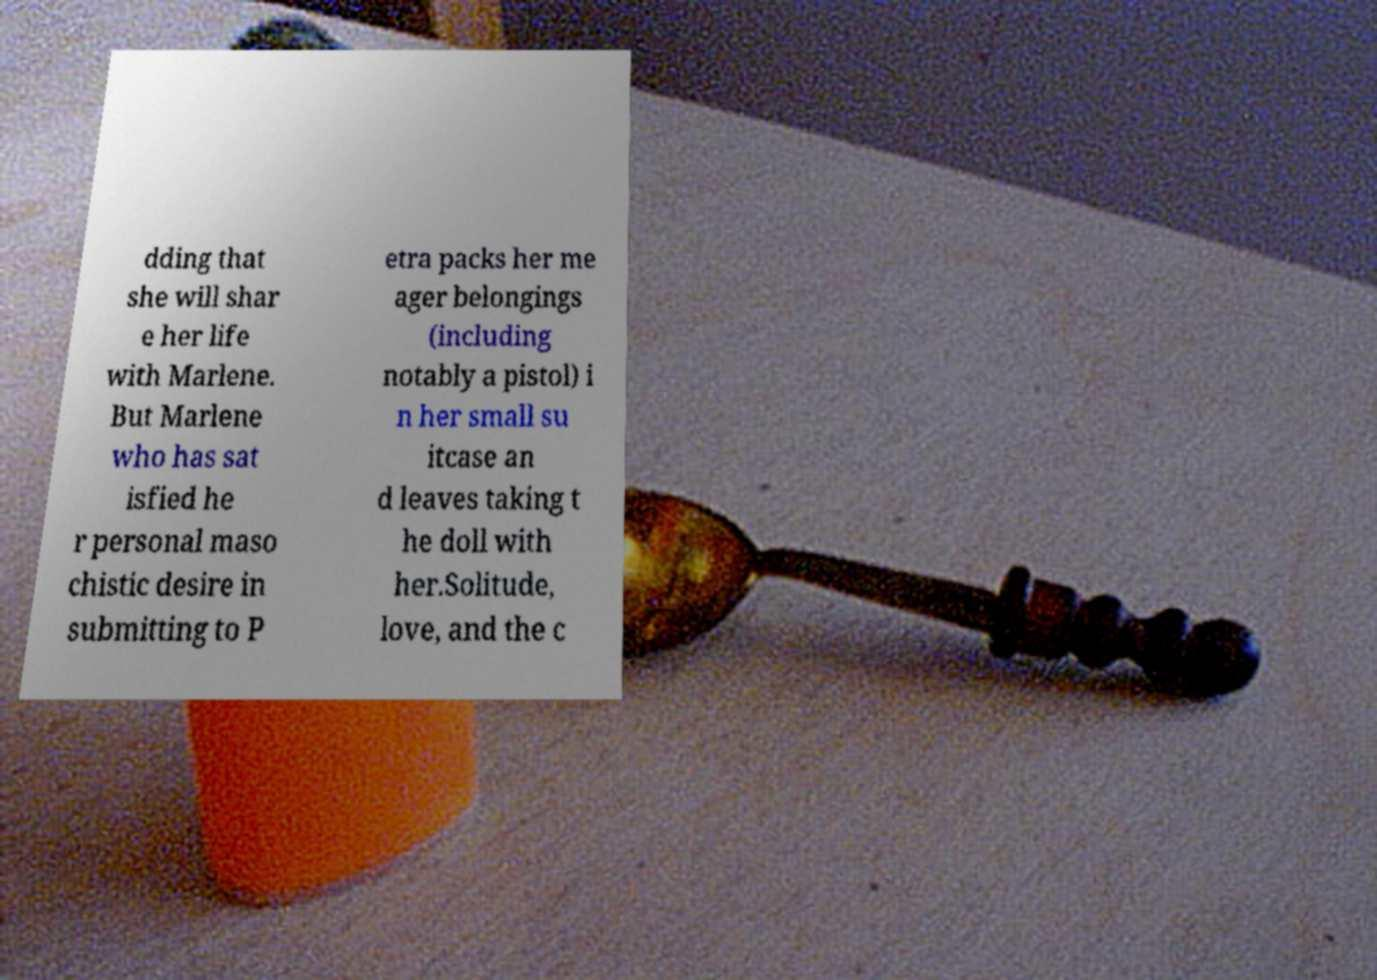Please identify and transcribe the text found in this image. dding that she will shar e her life with Marlene. But Marlene who has sat isfied he r personal maso chistic desire in submitting to P etra packs her me ager belongings (including notably a pistol) i n her small su itcase an d leaves taking t he doll with her.Solitude, love, and the c 